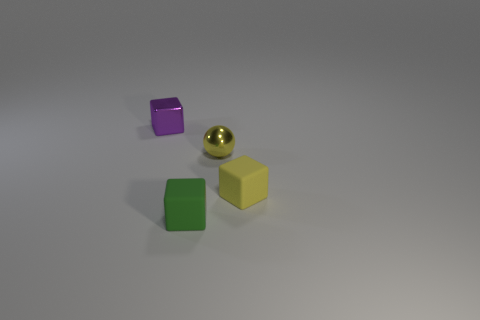Subtract all yellow cubes. How many cubes are left? 2 Add 2 big green shiny cylinders. How many objects exist? 6 Subtract all purple cubes. How many cubes are left? 2 Subtract all blocks. How many objects are left? 1 Subtract 1 spheres. How many spheres are left? 0 Subtract all gray balls. Subtract all blue cylinders. How many balls are left? 1 Subtract all yellow spheres. How many purple cubes are left? 1 Subtract all blue spheres. Subtract all tiny matte objects. How many objects are left? 2 Add 2 tiny yellow rubber cubes. How many tiny yellow rubber cubes are left? 3 Add 4 small green blocks. How many small green blocks exist? 5 